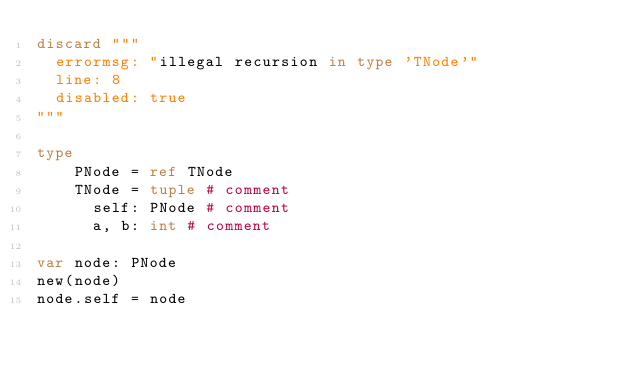<code> <loc_0><loc_0><loc_500><loc_500><_Nim_>discard """
  errormsg: "illegal recursion in type 'TNode'"
  line: 8
  disabled: true
"""

type
    PNode = ref TNode
    TNode = tuple # comment
      self: PNode # comment
      a, b: int # comment

var node: PNode
new(node)
node.self = node

</code> 